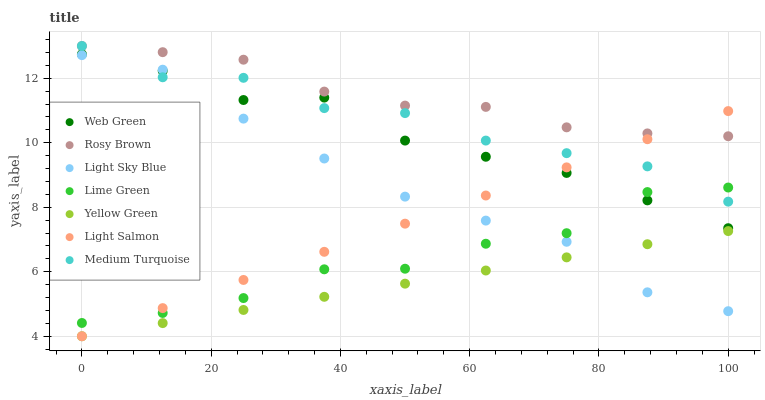Does Yellow Green have the minimum area under the curve?
Answer yes or no. Yes. Does Rosy Brown have the maximum area under the curve?
Answer yes or no. Yes. Does Rosy Brown have the minimum area under the curve?
Answer yes or no. No. Does Yellow Green have the maximum area under the curve?
Answer yes or no. No. Is Yellow Green the smoothest?
Answer yes or no. Yes. Is Lime Green the roughest?
Answer yes or no. Yes. Is Rosy Brown the smoothest?
Answer yes or no. No. Is Rosy Brown the roughest?
Answer yes or no. No. Does Light Salmon have the lowest value?
Answer yes or no. Yes. Does Rosy Brown have the lowest value?
Answer yes or no. No. Does Medium Turquoise have the highest value?
Answer yes or no. Yes. Does Yellow Green have the highest value?
Answer yes or no. No. Is Yellow Green less than Rosy Brown?
Answer yes or no. Yes. Is Lime Green greater than Yellow Green?
Answer yes or no. Yes. Does Light Salmon intersect Yellow Green?
Answer yes or no. Yes. Is Light Salmon less than Yellow Green?
Answer yes or no. No. Is Light Salmon greater than Yellow Green?
Answer yes or no. No. Does Yellow Green intersect Rosy Brown?
Answer yes or no. No. 